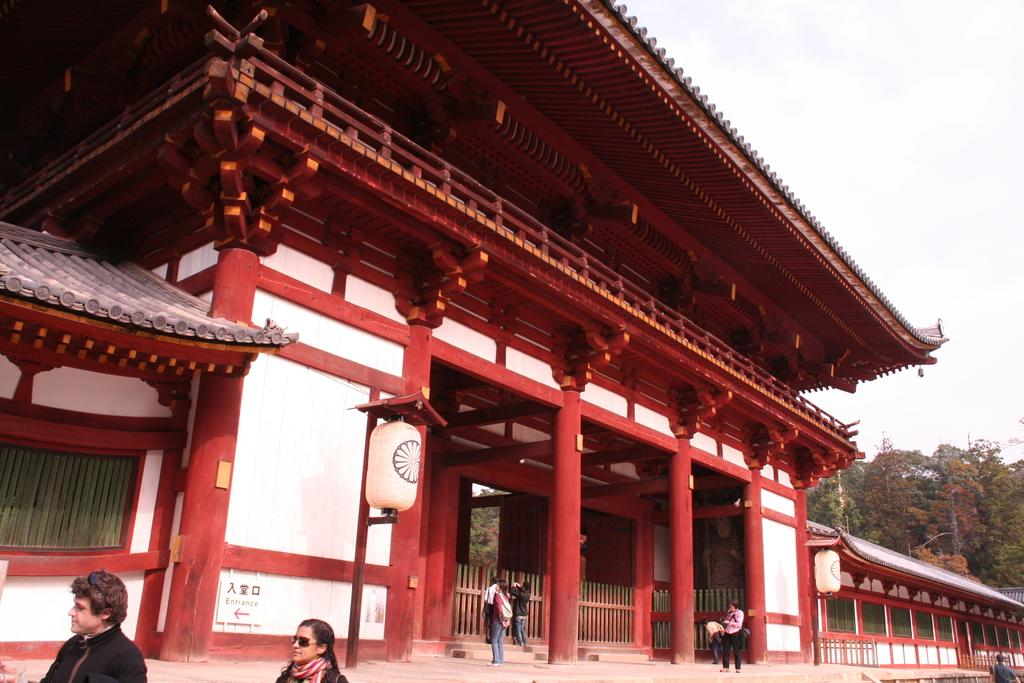What is the main structure in the image? There is a building in the image. What is happening in front of the building? There are people walking in front of the building. What type of vegetation is on the right side of the image? There are trees on the right side of the image. What type of news can be heard coming from the building in the image? There is no indication in the image that news is being broadcast from the building, so it's not possible to determine what, if any, news might be heard. 